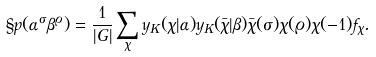<formula> <loc_0><loc_0><loc_500><loc_500>\S p ( { \alpha } ^ { \sigma } { \beta } ^ { \varrho } ) = \frac { 1 } { | G | } \sum _ { \chi } y _ { K } ( \chi | \alpha ) y _ { K } ( \bar { \chi } | \beta ) \bar { \chi } ( \sigma ) \chi ( \varrho ) \chi ( - 1 ) f _ { \chi } .</formula> 